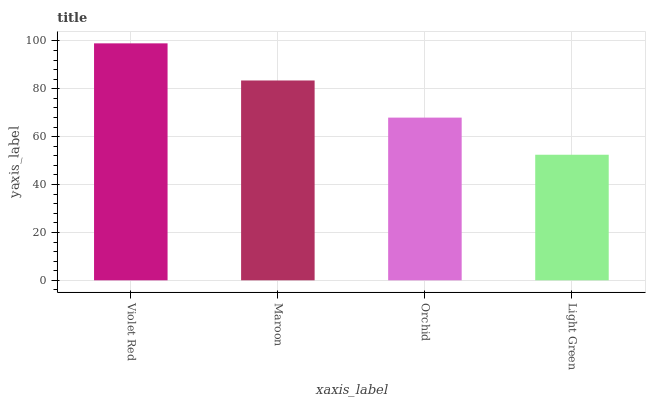Is Light Green the minimum?
Answer yes or no. Yes. Is Violet Red the maximum?
Answer yes or no. Yes. Is Maroon the minimum?
Answer yes or no. No. Is Maroon the maximum?
Answer yes or no. No. Is Violet Red greater than Maroon?
Answer yes or no. Yes. Is Maroon less than Violet Red?
Answer yes or no. Yes. Is Maroon greater than Violet Red?
Answer yes or no. No. Is Violet Red less than Maroon?
Answer yes or no. No. Is Maroon the high median?
Answer yes or no. Yes. Is Orchid the low median?
Answer yes or no. Yes. Is Violet Red the high median?
Answer yes or no. No. Is Light Green the low median?
Answer yes or no. No. 